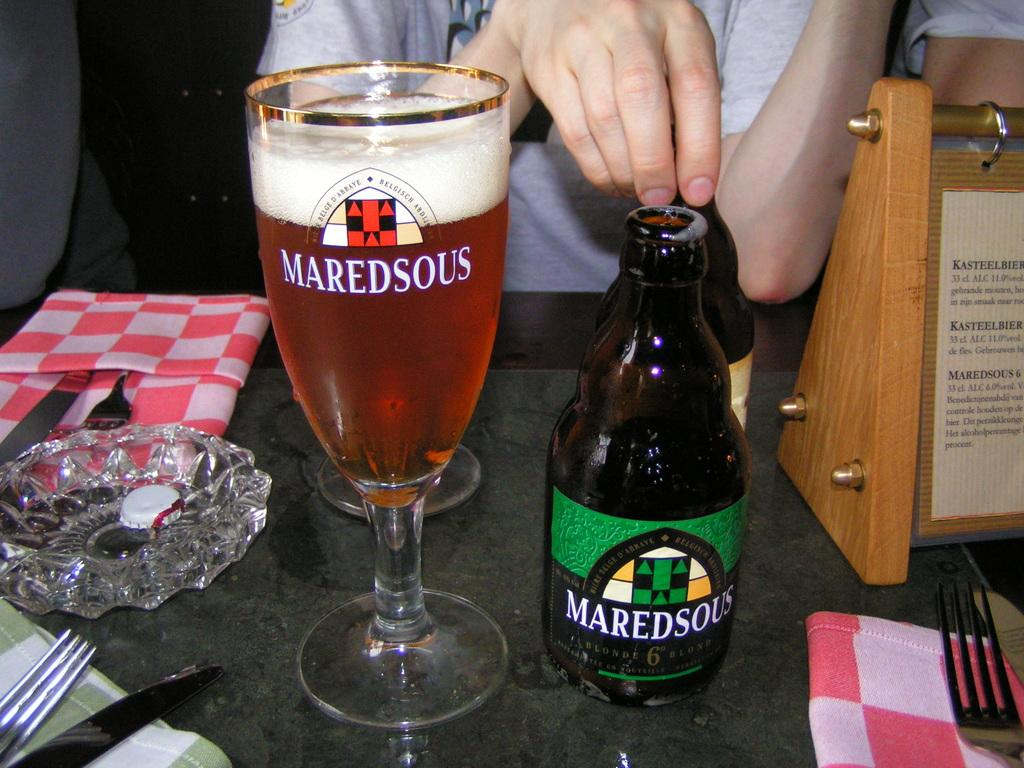Provide a one-sentence caption for the provided image. A glass of Maredsous, with the bottle next to it. 